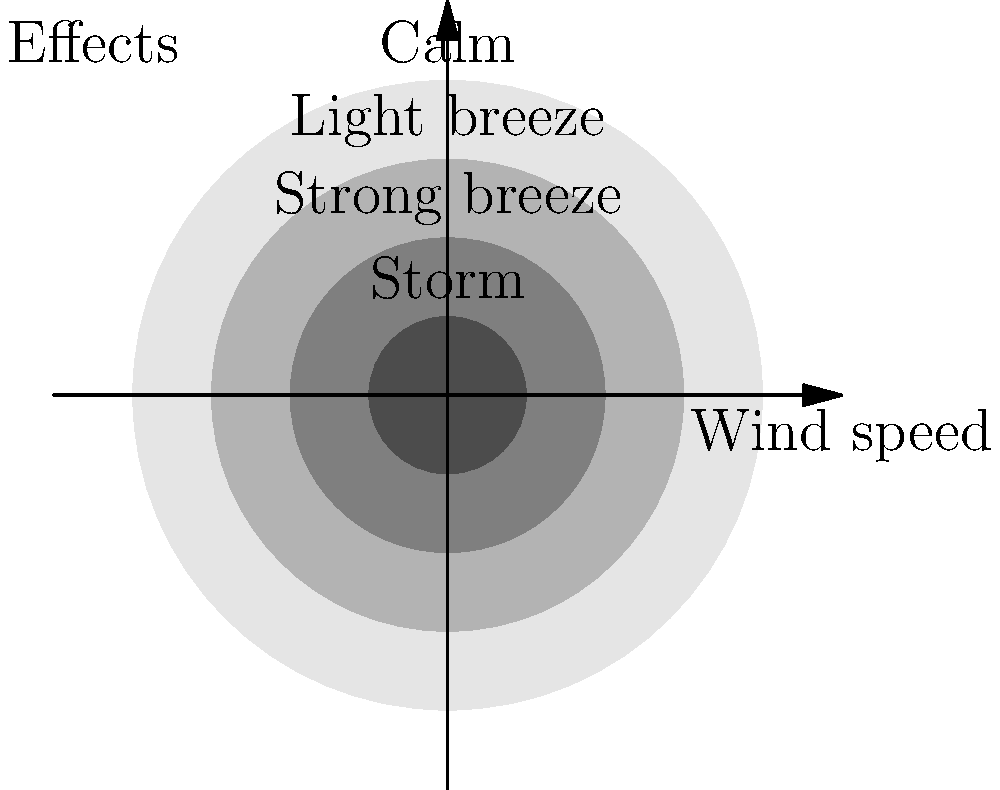As a first responder during a storm, you observe that large branches are in motion and whistling can be heard in overhead wires. Using the Beaufort scale represented in the image, estimate the wind speed range in km/h. To answer this question, we need to follow these steps:

1. Identify the observed effects: large branches in motion and whistling in overhead wires.

2. Compare these effects to the Beaufort scale representation in the image:
   - "Calm" (innermost circle) represents little to no wind.
   - "Light breeze" (second circle) represents gentle wind effects.
   - "Strong breeze" (third circle) represents noticeable wind effects on larger objects.
   - "Storm" (outermost circle) represents severe wind effects.

3. The described effects (large branches moving, whistling in wires) align with the "Strong breeze" category.

4. Recall the Beaufort scale wind speed ranges:
   - Strong breeze (Force 6) typically corresponds to wind speeds of 39-49 km/h (21-27 knots).

Therefore, based on the observed effects and the Beaufort scale representation, we can estimate the wind speed range to be 39-49 km/h.
Answer: 39-49 km/h 